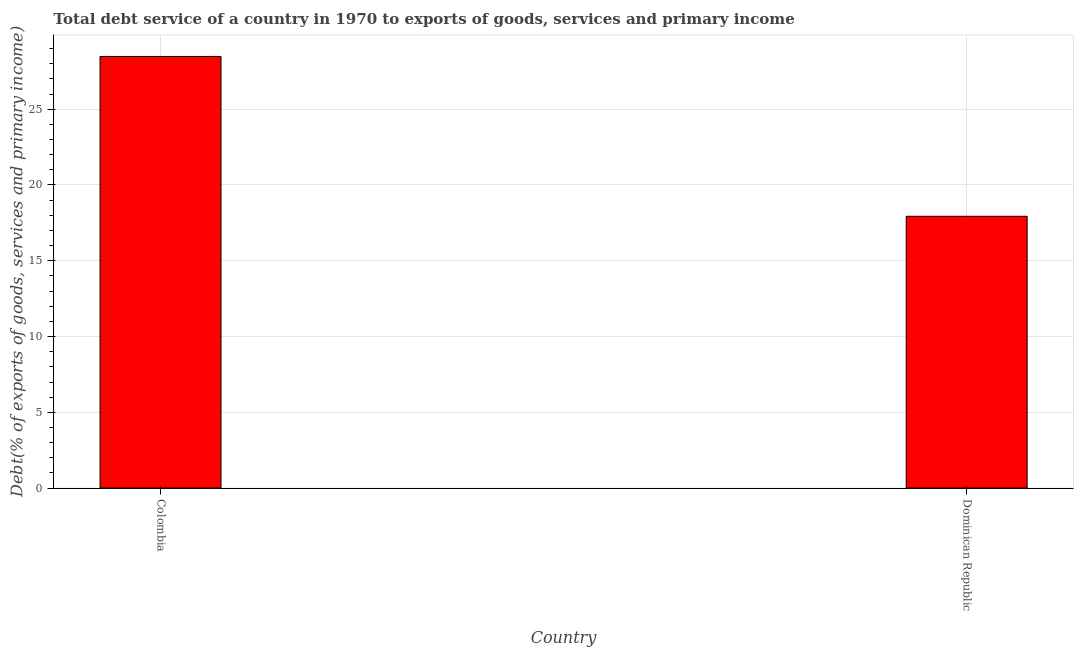Does the graph contain any zero values?
Provide a succinct answer. No. What is the title of the graph?
Make the answer very short. Total debt service of a country in 1970 to exports of goods, services and primary income. What is the label or title of the X-axis?
Your answer should be very brief. Country. What is the label or title of the Y-axis?
Give a very brief answer. Debt(% of exports of goods, services and primary income). What is the total debt service in Colombia?
Offer a terse response. 28.48. Across all countries, what is the maximum total debt service?
Offer a very short reply. 28.48. Across all countries, what is the minimum total debt service?
Make the answer very short. 17.93. In which country was the total debt service minimum?
Provide a succinct answer. Dominican Republic. What is the sum of the total debt service?
Keep it short and to the point. 46.42. What is the difference between the total debt service in Colombia and Dominican Republic?
Provide a succinct answer. 10.55. What is the average total debt service per country?
Ensure brevity in your answer.  23.21. What is the median total debt service?
Provide a short and direct response. 23.21. In how many countries, is the total debt service greater than 10 %?
Provide a succinct answer. 2. What is the ratio of the total debt service in Colombia to that in Dominican Republic?
Your answer should be very brief. 1.59. Is the total debt service in Colombia less than that in Dominican Republic?
Your answer should be compact. No. In how many countries, is the total debt service greater than the average total debt service taken over all countries?
Your answer should be very brief. 1. How many bars are there?
Offer a terse response. 2. What is the difference between two consecutive major ticks on the Y-axis?
Give a very brief answer. 5. What is the Debt(% of exports of goods, services and primary income) in Colombia?
Give a very brief answer. 28.48. What is the Debt(% of exports of goods, services and primary income) of Dominican Republic?
Provide a short and direct response. 17.93. What is the difference between the Debt(% of exports of goods, services and primary income) in Colombia and Dominican Republic?
Offer a terse response. 10.55. What is the ratio of the Debt(% of exports of goods, services and primary income) in Colombia to that in Dominican Republic?
Give a very brief answer. 1.59. 